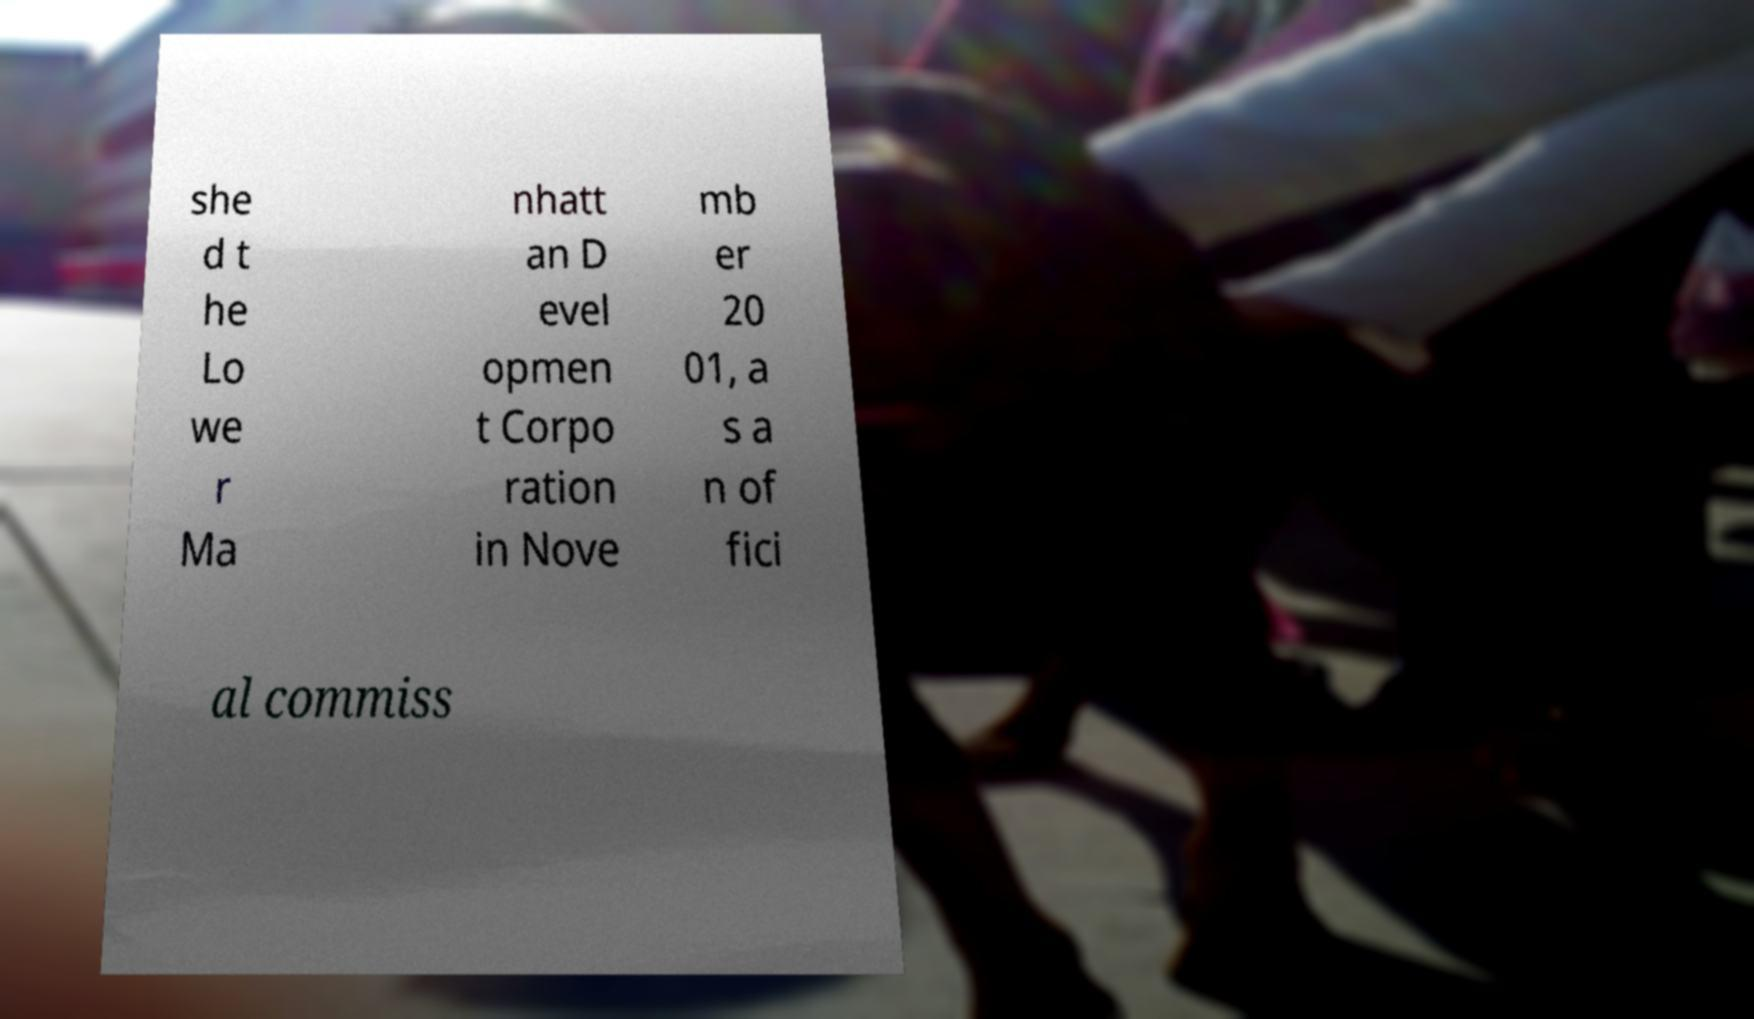I need the written content from this picture converted into text. Can you do that? she d t he Lo we r Ma nhatt an D evel opmen t Corpo ration in Nove mb er 20 01, a s a n of fici al commiss 